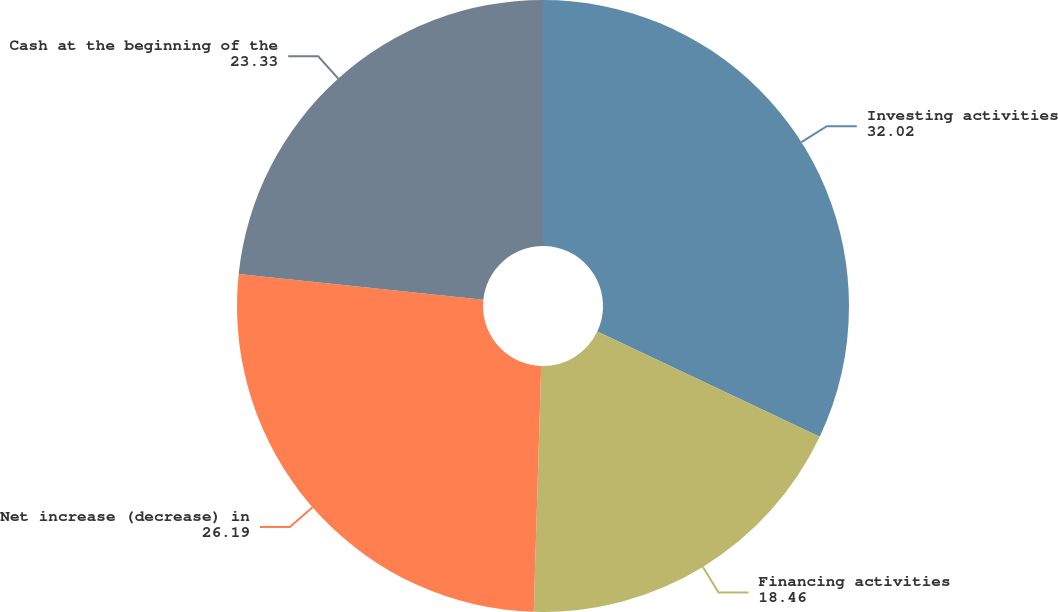Convert chart to OTSL. <chart><loc_0><loc_0><loc_500><loc_500><pie_chart><fcel>Investing activities<fcel>Financing activities<fcel>Net increase (decrease) in<fcel>Cash at the beginning of the<nl><fcel>32.02%<fcel>18.46%<fcel>26.19%<fcel>23.33%<nl></chart> 